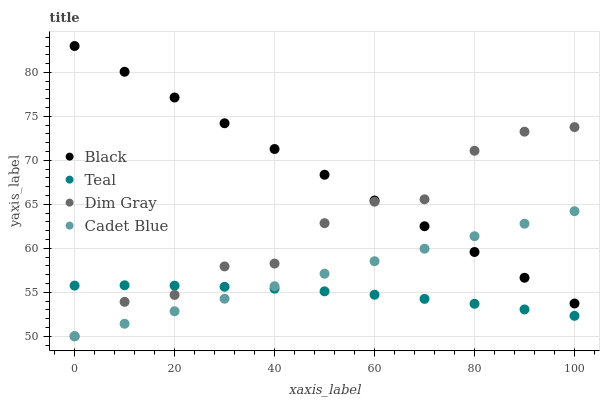Does Teal have the minimum area under the curve?
Answer yes or no. Yes. Does Black have the maximum area under the curve?
Answer yes or no. Yes. Does Dim Gray have the minimum area under the curve?
Answer yes or no. No. Does Dim Gray have the maximum area under the curve?
Answer yes or no. No. Is Cadet Blue the smoothest?
Answer yes or no. Yes. Is Dim Gray the roughest?
Answer yes or no. Yes. Is Black the smoothest?
Answer yes or no. No. Is Black the roughest?
Answer yes or no. No. Does Cadet Blue have the lowest value?
Answer yes or no. Yes. Does Black have the lowest value?
Answer yes or no. No. Does Black have the highest value?
Answer yes or no. Yes. Does Dim Gray have the highest value?
Answer yes or no. No. Is Teal less than Black?
Answer yes or no. Yes. Is Black greater than Teal?
Answer yes or no. Yes. Does Teal intersect Dim Gray?
Answer yes or no. Yes. Is Teal less than Dim Gray?
Answer yes or no. No. Is Teal greater than Dim Gray?
Answer yes or no. No. Does Teal intersect Black?
Answer yes or no. No. 